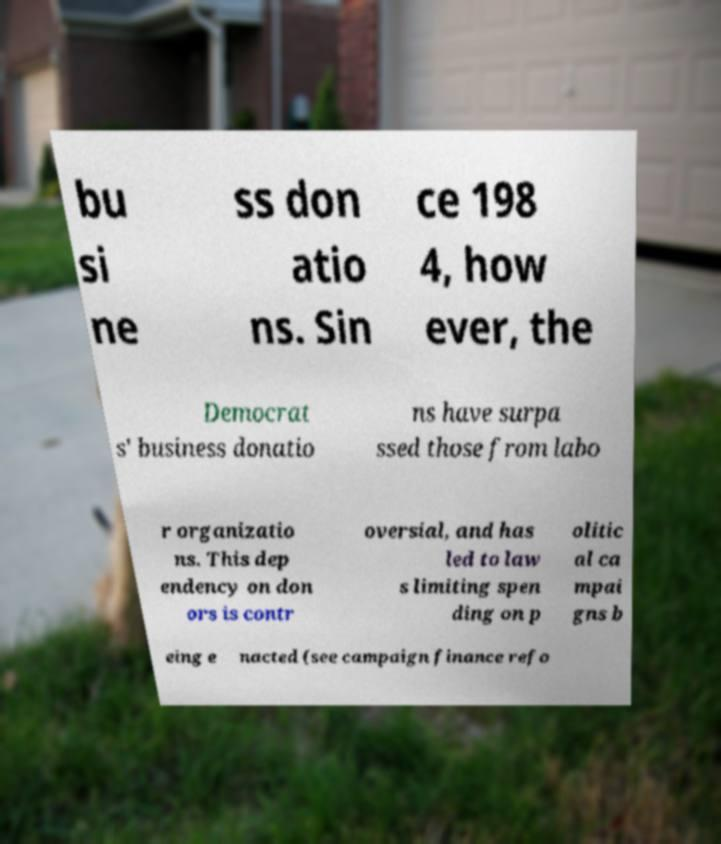I need the written content from this picture converted into text. Can you do that? bu si ne ss don atio ns. Sin ce 198 4, how ever, the Democrat s' business donatio ns have surpa ssed those from labo r organizatio ns. This dep endency on don ors is contr oversial, and has led to law s limiting spen ding on p olitic al ca mpai gns b eing e nacted (see campaign finance refo 